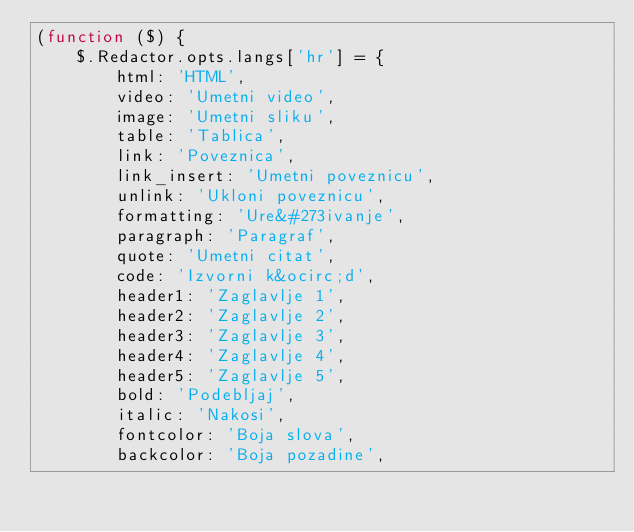Convert code to text. <code><loc_0><loc_0><loc_500><loc_500><_JavaScript_>(function ($) {
	$.Redactor.opts.langs['hr'] = {
		html: 'HTML',
		video: 'Umetni video',
		image: 'Umetni sliku',
		table: 'Tablica',
		link: 'Poveznica',
		link_insert: 'Umetni poveznicu',
		unlink: 'Ukloni poveznicu',
		formatting: 'Ure&#273ivanje',
		paragraph: 'Paragraf',
		quote: 'Umetni citat',
		code: 'Izvorni k&ocirc;d',
		header1: 'Zaglavlje 1',
		header2: 'Zaglavlje 2',
		header3: 'Zaglavlje 3',
		header4: 'Zaglavlje 4',
		header5: 'Zaglavlje 5',
		bold: 'Podebljaj',
		italic: 'Nakosi',
		fontcolor: 'Boja slova',
		backcolor: 'Boja pozadine',</code> 